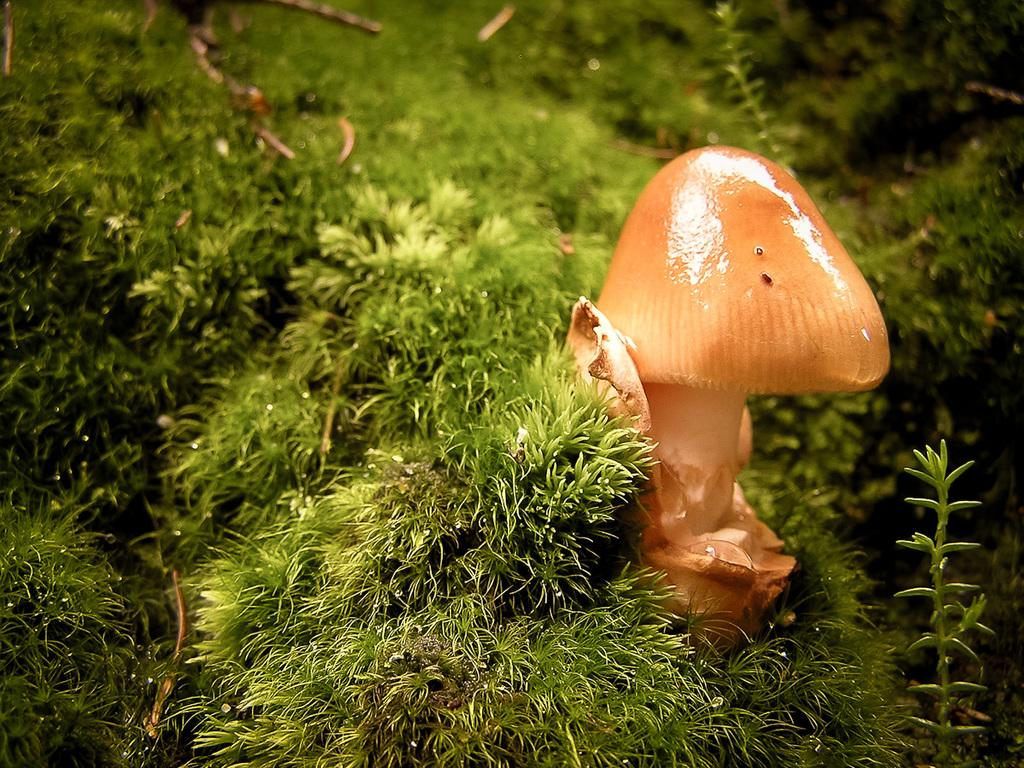What type of fungus can be seen on the right side of the image? There is a mushroom on the right side of the image. What type of vegetation surrounds the mushroom? There is grass surrounding the mushroom. What other plant can be seen in the image? There is a plant in the bottom right corner of the image. What type of meeting is taking place in the image? There is no meeting present in the image; it features a mushroom, grass, and a plant. How many plantations are visible in the image? There are no plantations present in the image; it features a mushroom, grass, and a plant. 